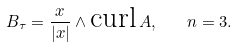Convert formula to latex. <formula><loc_0><loc_0><loc_500><loc_500>B _ { \tau } = \frac { x } { | x | } \wedge \text {curl} \, A , \quad n = 3 .</formula> 